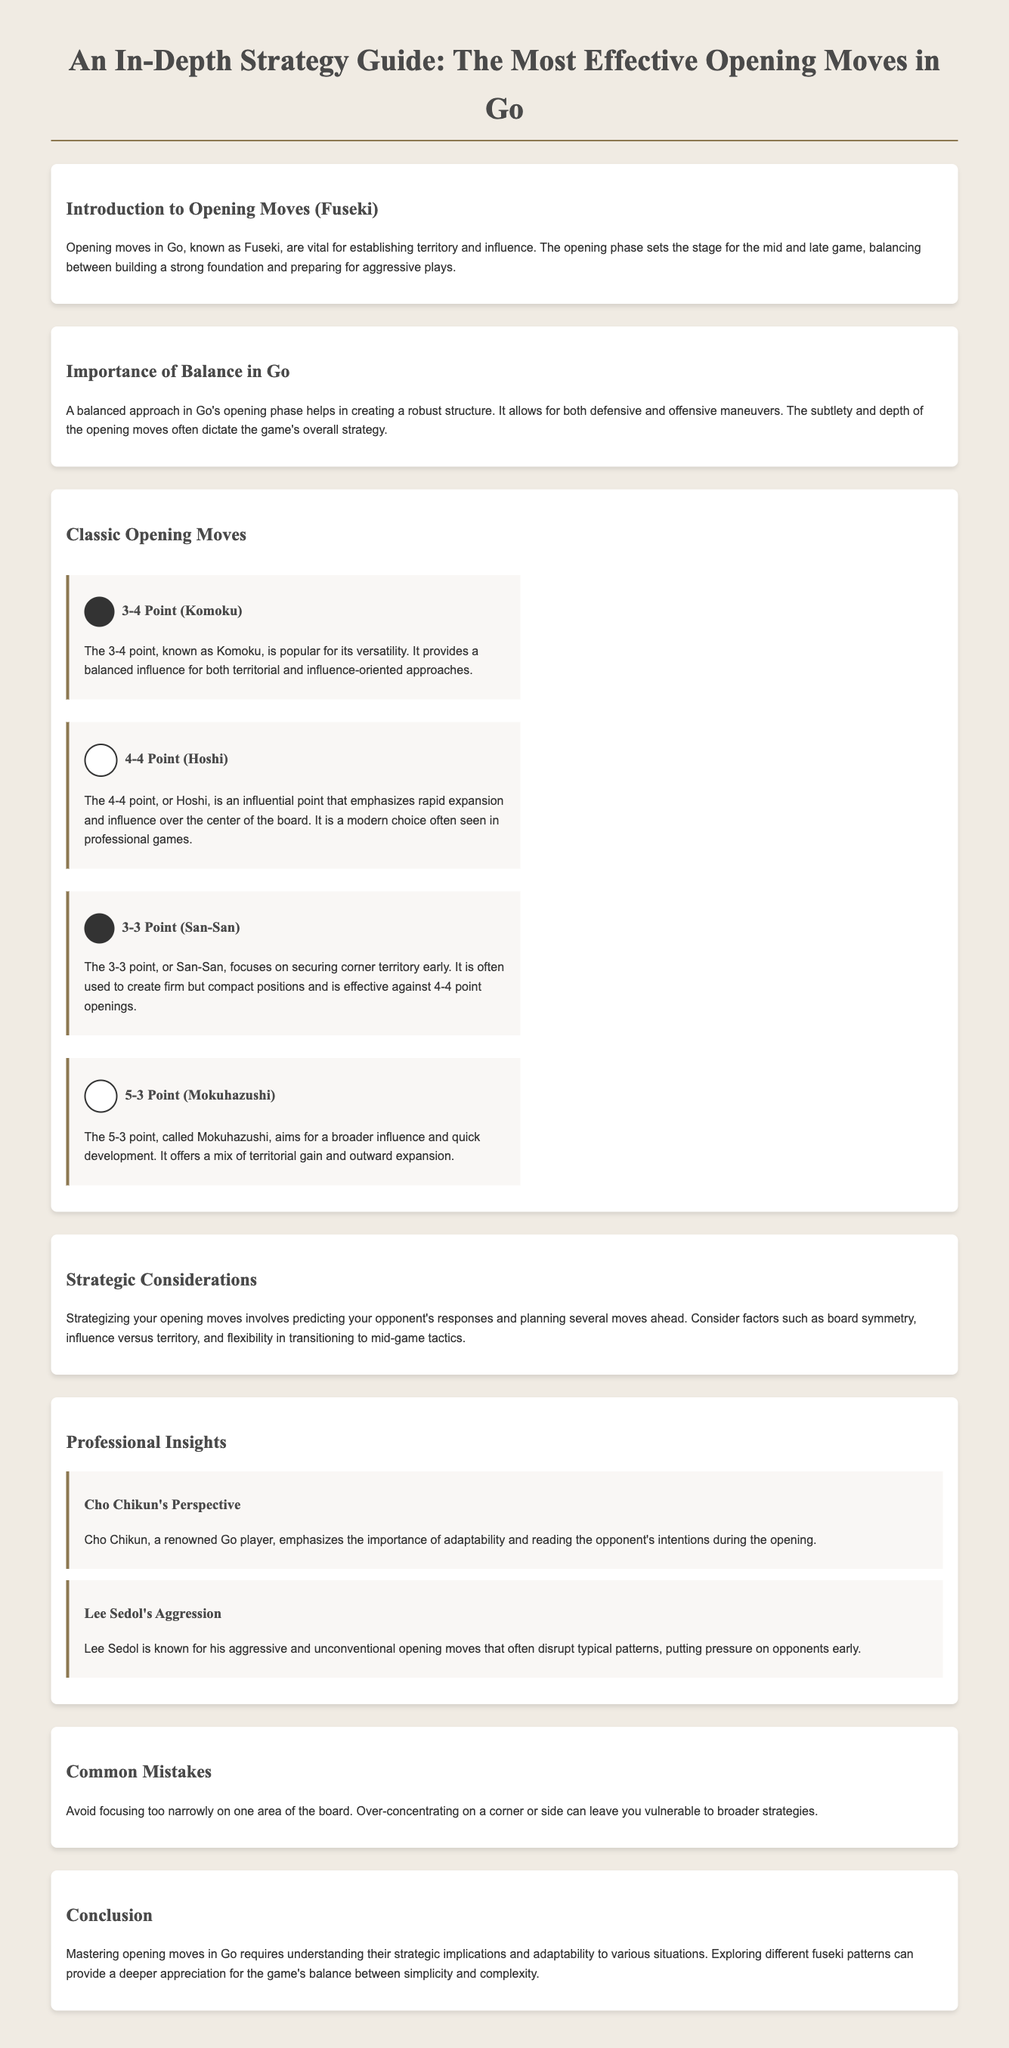What are opening moves in Go known as? The document states that opening moves in Go are known as Fuseki.
Answer: Fuseki What is the 3-4 point called? In the document, the 3-4 point is referred to as Komoku.
Answer: Komoku Which point emphasizes rapid expansion and influence? The document mentions the 4-4 point, or Hoshi, as emphasizing rapid expansion and influence.
Answer: Hoshi Who emphasizes the importance of adaptability in Go? According to the document, Cho Chikun emphasizes adaptability during the opening.
Answer: Cho Chikun What is a common mistake to avoid in Go? The document advises against focusing too narrowly on one area of the board as a common mistake.
Answer: Over-concentrating What does mastering opening moves require? The conclusion states that mastering opening moves requires understanding strategic implications.
Answer: Understanding strategic implications 